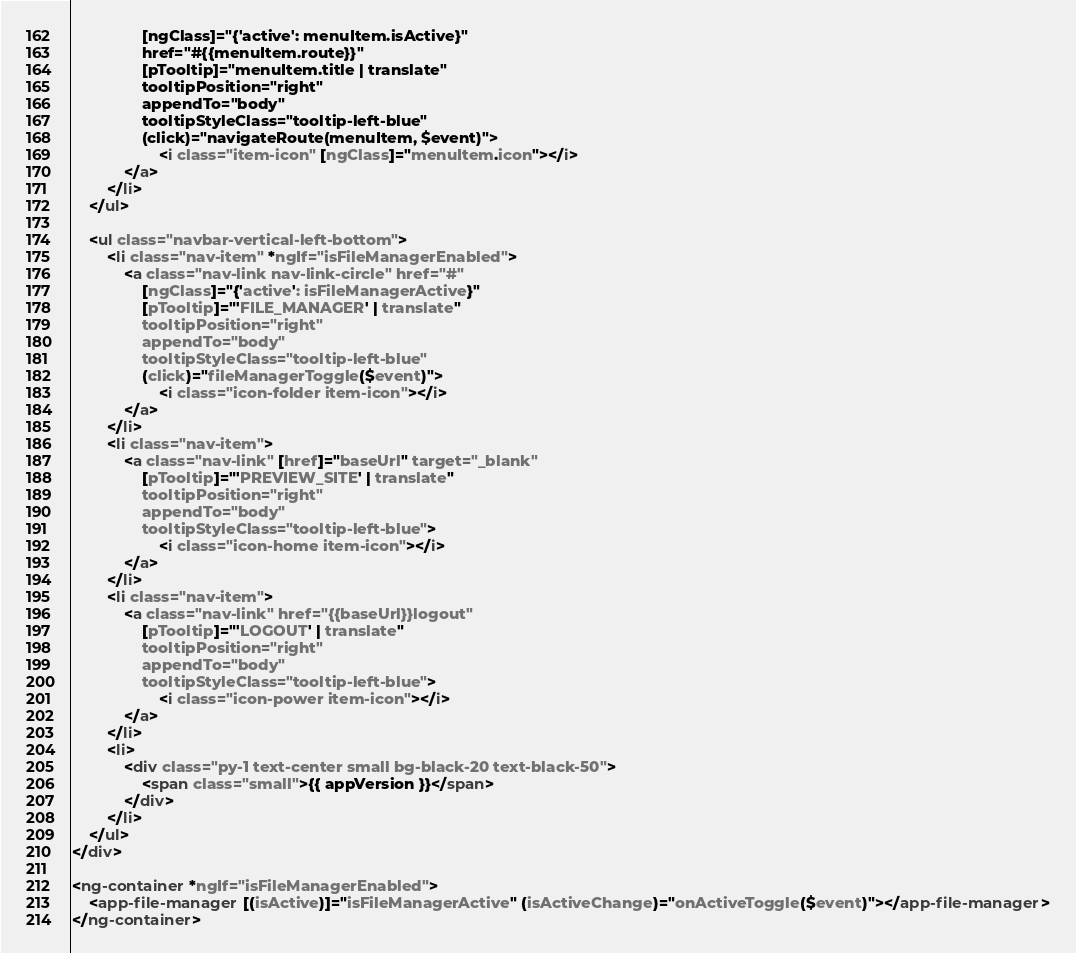Convert code to text. <code><loc_0><loc_0><loc_500><loc_500><_HTML_>                [ngClass]="{'active': menuItem.isActive}"
                href="#{{menuItem.route}}"
                [pTooltip]="menuItem.title | translate"
                tooltipPosition="right"
                appendTo="body"
                tooltipStyleClass="tooltip-left-blue"
                (click)="navigateRoute(menuItem, $event)">
                    <i class="item-icon" [ngClass]="menuItem.icon"></i>
            </a>
        </li>
    </ul>

    <ul class="navbar-vertical-left-bottom">
        <li class="nav-item" *ngIf="isFileManagerEnabled">
            <a class="nav-link nav-link-circle" href="#"
                [ngClass]="{'active': isFileManagerActive}"
                [pTooltip]="'FILE_MANAGER' | translate"
                tooltipPosition="right"
                appendTo="body"
                tooltipStyleClass="tooltip-left-blue"
                (click)="fileManagerToggle($event)">
                    <i class="icon-folder item-icon"></i>
            </a>
        </li>
        <li class="nav-item">
            <a class="nav-link" [href]="baseUrl" target="_blank"
                [pTooltip]="'PREVIEW_SITE' | translate"
                tooltipPosition="right"
                appendTo="body"
                tooltipStyleClass="tooltip-left-blue">
                    <i class="icon-home item-icon"></i>
            </a>
        </li>
        <li class="nav-item">
            <a class="nav-link" href="{{baseUrl}}logout"
                [pTooltip]="'LOGOUT' | translate"
                tooltipPosition="right"
                appendTo="body"
                tooltipStyleClass="tooltip-left-blue">
                    <i class="icon-power item-icon"></i>
            </a>
        </li>
        <li>
            <div class="py-1 text-center small bg-black-20 text-black-50">
                <span class="small">{{ appVersion }}</span>
            </div>
        </li>
    </ul>
</div>

<ng-container *ngIf="isFileManagerEnabled">
    <app-file-manager [(isActive)]="isFileManagerActive" (isActiveChange)="onActiveToggle($event)"></app-file-manager>
</ng-container>
</code> 